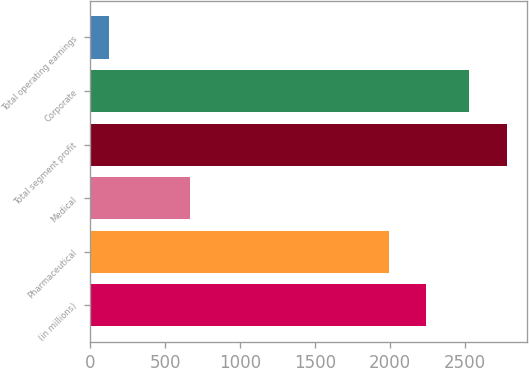<chart> <loc_0><loc_0><loc_500><loc_500><bar_chart><fcel>(in millions)<fcel>Pharmaceutical<fcel>Medical<fcel>Total segment profit<fcel>Corporate<fcel>Total operating earnings<nl><fcel>2244.8<fcel>1992<fcel>662<fcel>2780.8<fcel>2528<fcel>126<nl></chart> 